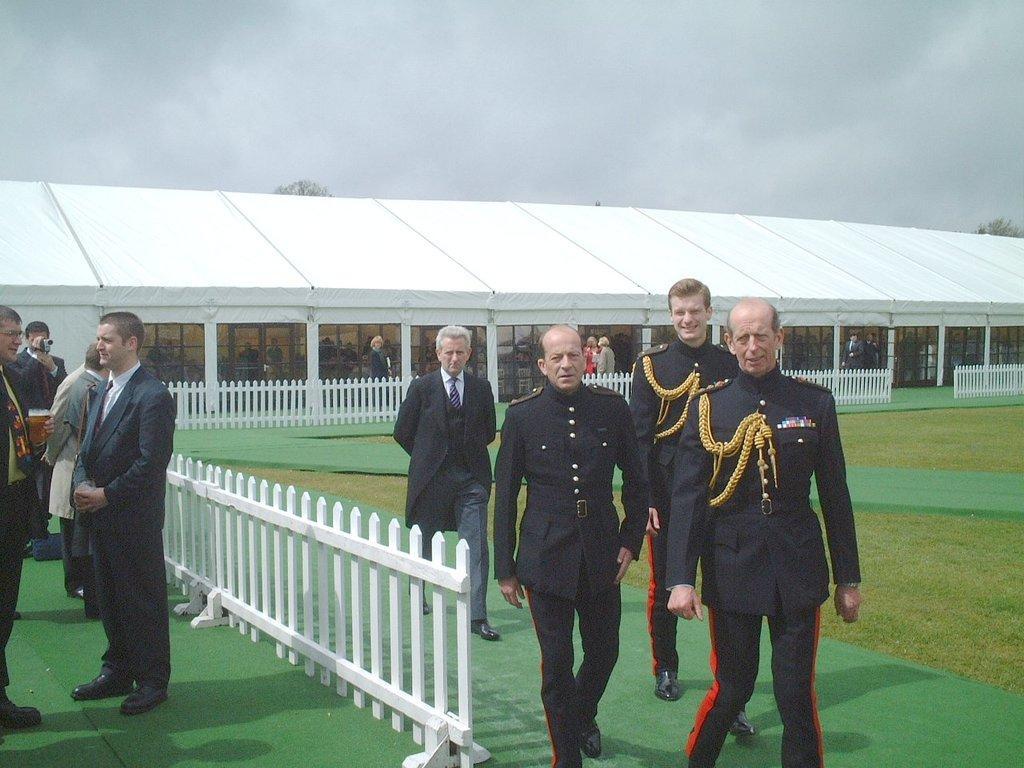How would you summarize this image in a sentence or two? In the center of the image we can see four persons are walking and they are smiling, which we can see on their faces. And they are in different costumes. On the left side of the image we can see a few people are standing and the middle person is holding a camera. In the background we can see the sky, clouds, one building, pillars, fences, carpet, few people are standing and a few other objects. 